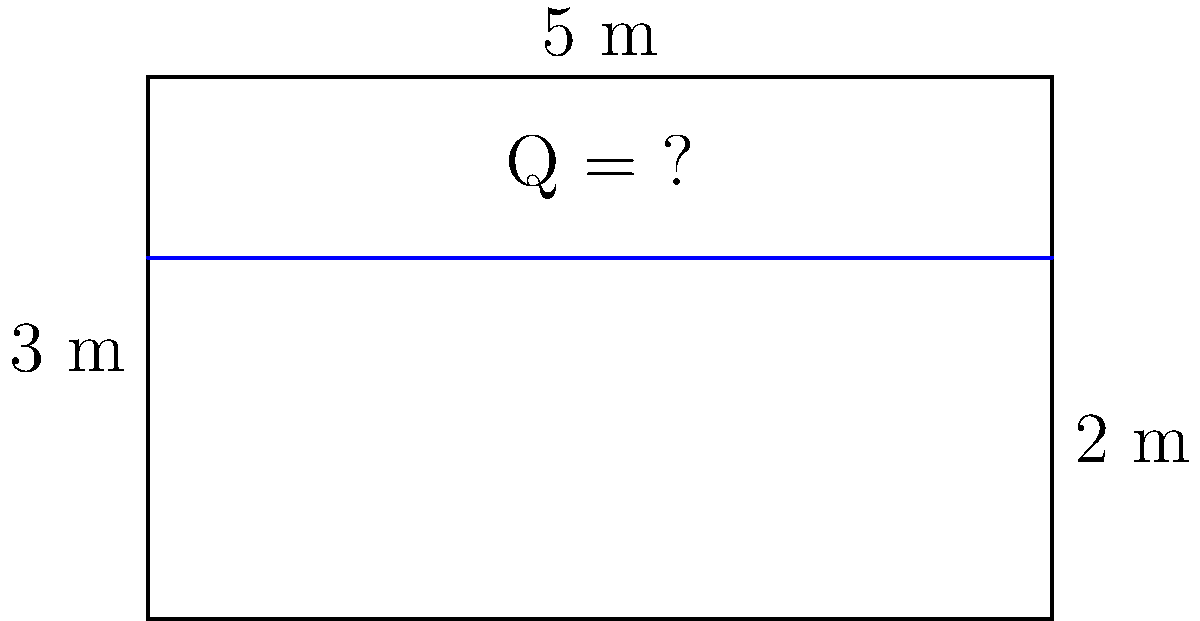As an IT administrator troubleshooting clipboard-related issues, you encounter a Civil Engineering problem during a system update. The problem involves calculating the flow rate in an open rectangular channel. Given the channel's width of 5 m, depth of 3 m, and a water depth of 2 m, determine the flow rate if the average velocity is 1.5 m/s. Assume the Manning's roughness coefficient (n) is 0.013 for concrete. To solve this problem, we'll use the continuity equation for flow rate:

1. The continuity equation: $Q = A \times v$
   Where:
   $Q$ = flow rate (m³/s)
   $A$ = cross-sectional area of flow (m²)
   $v$ = average velocity (m/s)

2. Calculate the cross-sectional area of flow:
   $A = \text{width} \times \text{water depth}$
   $A = 5 \text{ m} \times 2 \text{ m} = 10 \text{ m}^2$

3. We're given the average velocity:
   $v = 1.5 \text{ m/s}$

4. Now, we can calculate the flow rate:
   $Q = A \times v$
   $Q = 10 \text{ m}^2 \times 1.5 \text{ m/s}$
   $Q = 15 \text{ m}^3/\text{s}$

Note: The Manning's roughness coefficient (n) wasn't needed for this calculation, but it could be used to verify the average velocity if it wasn't given.
Answer: 15 m³/s 